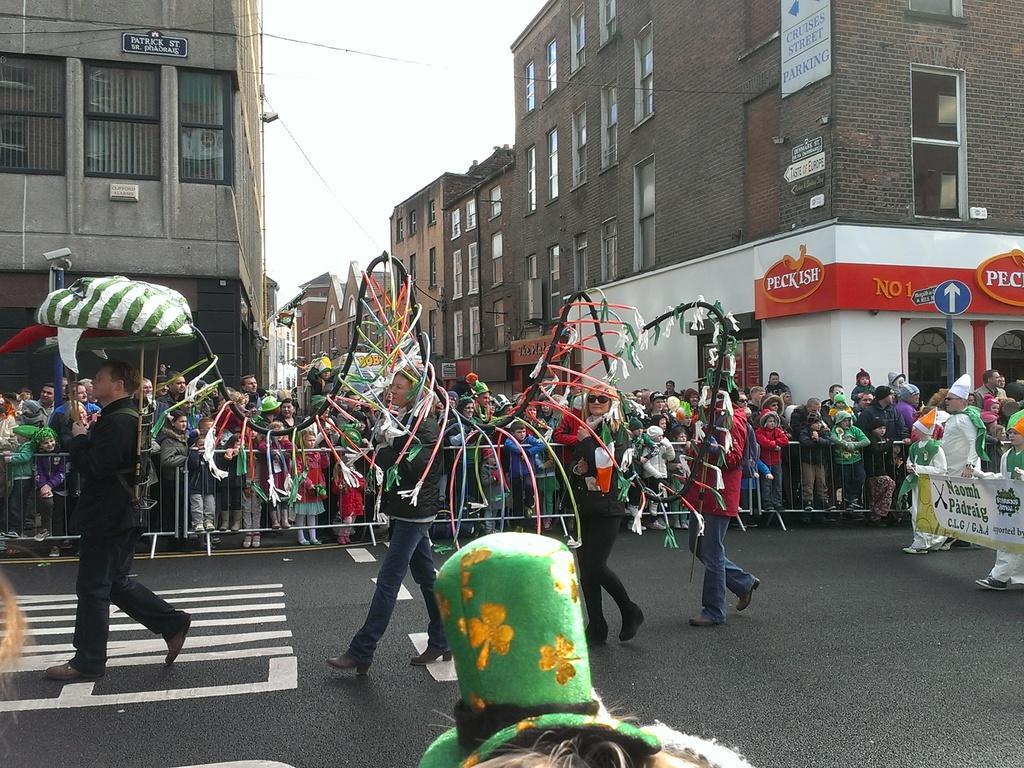In one or two sentences, can you explain what this image depicts? Here we can see group of people on the road. There are few persons walking on the road and they are holding an object. Here we can see banners, boards, pole, and buildings. In the background there is sky. 